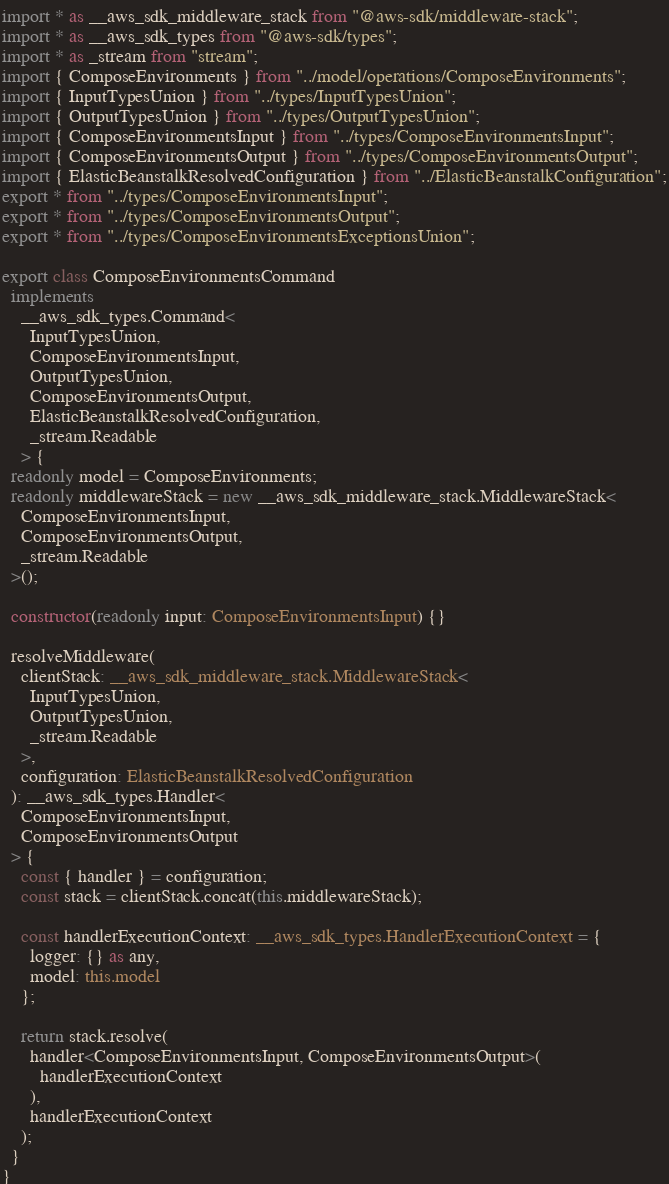<code> <loc_0><loc_0><loc_500><loc_500><_TypeScript_>import * as __aws_sdk_middleware_stack from "@aws-sdk/middleware-stack";
import * as __aws_sdk_types from "@aws-sdk/types";
import * as _stream from "stream";
import { ComposeEnvironments } from "../model/operations/ComposeEnvironments";
import { InputTypesUnion } from "../types/InputTypesUnion";
import { OutputTypesUnion } from "../types/OutputTypesUnion";
import { ComposeEnvironmentsInput } from "../types/ComposeEnvironmentsInput";
import { ComposeEnvironmentsOutput } from "../types/ComposeEnvironmentsOutput";
import { ElasticBeanstalkResolvedConfiguration } from "../ElasticBeanstalkConfiguration";
export * from "../types/ComposeEnvironmentsInput";
export * from "../types/ComposeEnvironmentsOutput";
export * from "../types/ComposeEnvironmentsExceptionsUnion";

export class ComposeEnvironmentsCommand
  implements
    __aws_sdk_types.Command<
      InputTypesUnion,
      ComposeEnvironmentsInput,
      OutputTypesUnion,
      ComposeEnvironmentsOutput,
      ElasticBeanstalkResolvedConfiguration,
      _stream.Readable
    > {
  readonly model = ComposeEnvironments;
  readonly middlewareStack = new __aws_sdk_middleware_stack.MiddlewareStack<
    ComposeEnvironmentsInput,
    ComposeEnvironmentsOutput,
    _stream.Readable
  >();

  constructor(readonly input: ComposeEnvironmentsInput) {}

  resolveMiddleware(
    clientStack: __aws_sdk_middleware_stack.MiddlewareStack<
      InputTypesUnion,
      OutputTypesUnion,
      _stream.Readable
    >,
    configuration: ElasticBeanstalkResolvedConfiguration
  ): __aws_sdk_types.Handler<
    ComposeEnvironmentsInput,
    ComposeEnvironmentsOutput
  > {
    const { handler } = configuration;
    const stack = clientStack.concat(this.middlewareStack);

    const handlerExecutionContext: __aws_sdk_types.HandlerExecutionContext = {
      logger: {} as any,
      model: this.model
    };

    return stack.resolve(
      handler<ComposeEnvironmentsInput, ComposeEnvironmentsOutput>(
        handlerExecutionContext
      ),
      handlerExecutionContext
    );
  }
}
</code> 